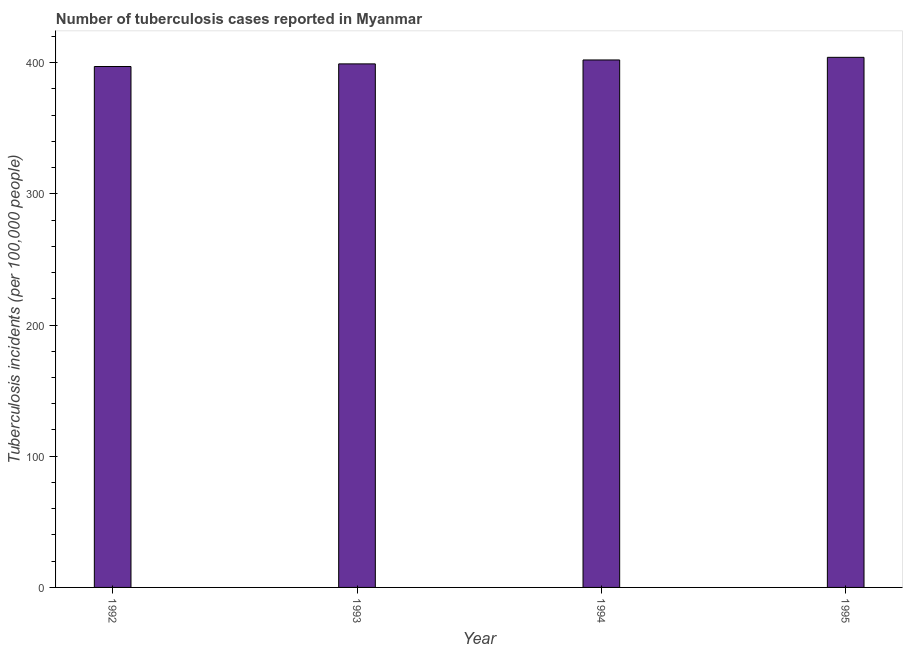Does the graph contain any zero values?
Your response must be concise. No. What is the title of the graph?
Your answer should be compact. Number of tuberculosis cases reported in Myanmar. What is the label or title of the Y-axis?
Offer a very short reply. Tuberculosis incidents (per 100,0 people). What is the number of tuberculosis incidents in 1992?
Your response must be concise. 397. Across all years, what is the maximum number of tuberculosis incidents?
Your response must be concise. 404. Across all years, what is the minimum number of tuberculosis incidents?
Offer a terse response. 397. In which year was the number of tuberculosis incidents maximum?
Your answer should be very brief. 1995. In which year was the number of tuberculosis incidents minimum?
Your answer should be compact. 1992. What is the sum of the number of tuberculosis incidents?
Give a very brief answer. 1602. What is the median number of tuberculosis incidents?
Your answer should be very brief. 400.5. What is the ratio of the number of tuberculosis incidents in 1994 to that in 1995?
Your answer should be very brief. 0.99. Is the number of tuberculosis incidents in 1992 less than that in 1993?
Your response must be concise. Yes. Is the difference between the number of tuberculosis incidents in 1993 and 1994 greater than the difference between any two years?
Give a very brief answer. No. What is the difference between the highest and the second highest number of tuberculosis incidents?
Keep it short and to the point. 2. Is the sum of the number of tuberculosis incidents in 1992 and 1995 greater than the maximum number of tuberculosis incidents across all years?
Your answer should be compact. Yes. In how many years, is the number of tuberculosis incidents greater than the average number of tuberculosis incidents taken over all years?
Make the answer very short. 2. Are all the bars in the graph horizontal?
Offer a terse response. No. How many years are there in the graph?
Your answer should be very brief. 4. What is the difference between two consecutive major ticks on the Y-axis?
Give a very brief answer. 100. Are the values on the major ticks of Y-axis written in scientific E-notation?
Your response must be concise. No. What is the Tuberculosis incidents (per 100,000 people) of 1992?
Offer a very short reply. 397. What is the Tuberculosis incidents (per 100,000 people) of 1993?
Your answer should be compact. 399. What is the Tuberculosis incidents (per 100,000 people) in 1994?
Provide a short and direct response. 402. What is the Tuberculosis incidents (per 100,000 people) of 1995?
Give a very brief answer. 404. What is the difference between the Tuberculosis incidents (per 100,000 people) in 1992 and 1993?
Your response must be concise. -2. What is the difference between the Tuberculosis incidents (per 100,000 people) in 1992 and 1994?
Your answer should be compact. -5. What is the difference between the Tuberculosis incidents (per 100,000 people) in 1993 and 1994?
Provide a short and direct response. -3. What is the difference between the Tuberculosis incidents (per 100,000 people) in 1994 and 1995?
Ensure brevity in your answer.  -2. What is the ratio of the Tuberculosis incidents (per 100,000 people) in 1992 to that in 1994?
Your answer should be compact. 0.99. What is the ratio of the Tuberculosis incidents (per 100,000 people) in 1993 to that in 1994?
Give a very brief answer. 0.99. What is the ratio of the Tuberculosis incidents (per 100,000 people) in 1993 to that in 1995?
Your response must be concise. 0.99. 